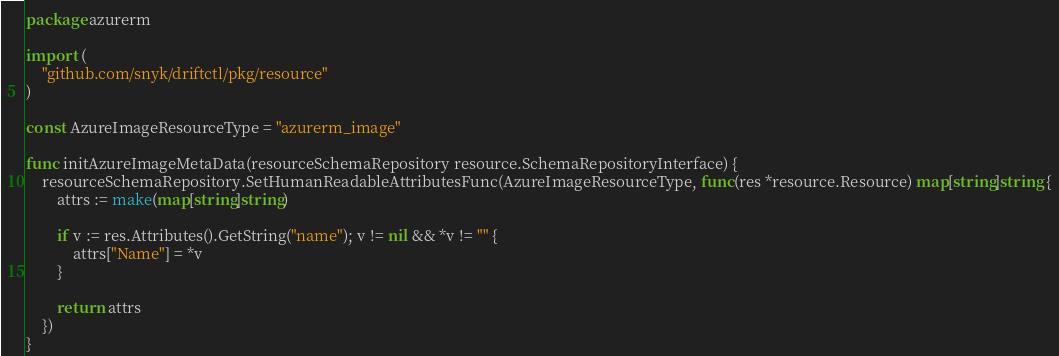<code> <loc_0><loc_0><loc_500><loc_500><_Go_>package azurerm

import (
	"github.com/snyk/driftctl/pkg/resource"
)

const AzureImageResourceType = "azurerm_image"

func initAzureImageMetaData(resourceSchemaRepository resource.SchemaRepositoryInterface) {
	resourceSchemaRepository.SetHumanReadableAttributesFunc(AzureImageResourceType, func(res *resource.Resource) map[string]string {
		attrs := make(map[string]string)

		if v := res.Attributes().GetString("name"); v != nil && *v != "" {
			attrs["Name"] = *v
		}

		return attrs
	})
}
</code> 